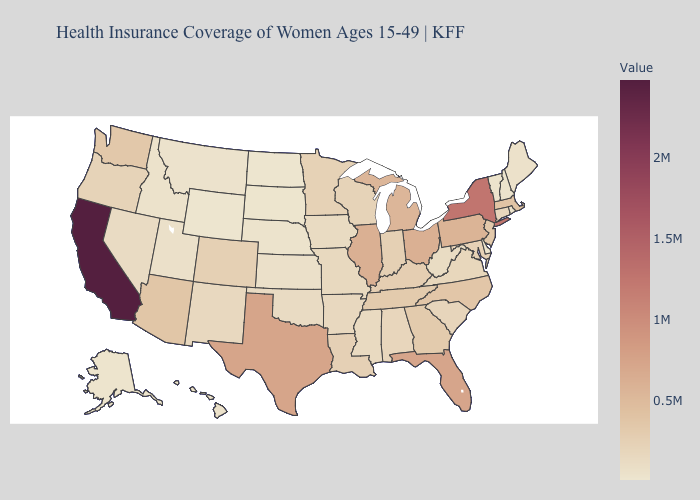Which states have the lowest value in the West?
Be succinct. Wyoming. Does Idaho have the lowest value in the USA?
Give a very brief answer. No. Which states hav the highest value in the MidWest?
Give a very brief answer. Illinois. Among the states that border Arkansas , does Oklahoma have the lowest value?
Give a very brief answer. Yes. 